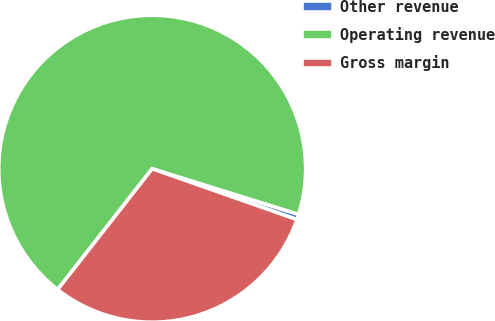Convert chart to OTSL. <chart><loc_0><loc_0><loc_500><loc_500><pie_chart><fcel>Other revenue<fcel>Operating revenue<fcel>Gross margin<nl><fcel>0.57%<fcel>69.24%<fcel>30.19%<nl></chart> 